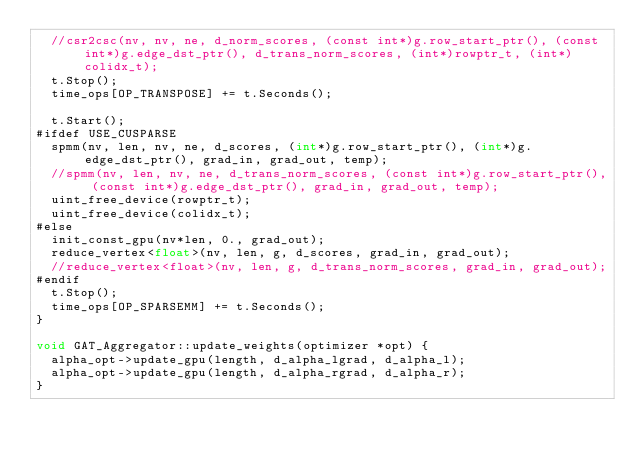<code> <loc_0><loc_0><loc_500><loc_500><_Cuda_>  //csr2csc(nv, nv, ne, d_norm_scores, (const int*)g.row_start_ptr(), (const int*)g.edge_dst_ptr(), d_trans_norm_scores, (int*)rowptr_t, (int*)colidx_t);
  t.Stop();
  time_ops[OP_TRANSPOSE] += t.Seconds();

  t.Start();
#ifdef USE_CUSPARSE
  spmm(nv, len, nv, ne, d_scores, (int*)g.row_start_ptr(), (int*)g.edge_dst_ptr(), grad_in, grad_out, temp);
  //spmm(nv, len, nv, ne, d_trans_norm_scores, (const int*)g.row_start_ptr(), (const int*)g.edge_dst_ptr(), grad_in, grad_out, temp);
  uint_free_device(rowptr_t);
  uint_free_device(colidx_t);
#else
  init_const_gpu(nv*len, 0., grad_out);
  reduce_vertex<float>(nv, len, g, d_scores, grad_in, grad_out);
  //reduce_vertex<float>(nv, len, g, d_trans_norm_scores, grad_in, grad_out);
#endif
  t.Stop();
  time_ops[OP_SPARSEMM] += t.Seconds();
}

void GAT_Aggregator::update_weights(optimizer *opt) {
  alpha_opt->update_gpu(length, d_alpha_lgrad, d_alpha_l);
  alpha_opt->update_gpu(length, d_alpha_rgrad, d_alpha_r);
}

</code> 